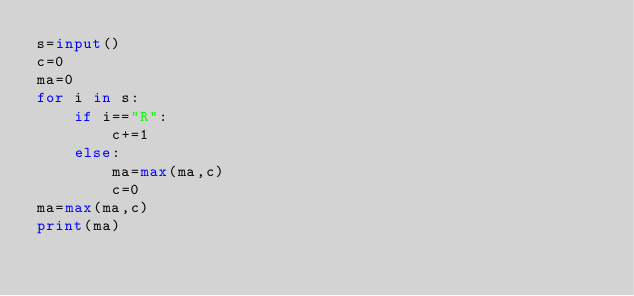<code> <loc_0><loc_0><loc_500><loc_500><_Python_>s=input()
c=0
ma=0
for i in s:
    if i=="R":
        c+=1
    else:
        ma=max(ma,c)
        c=0
ma=max(ma,c)
print(ma)</code> 